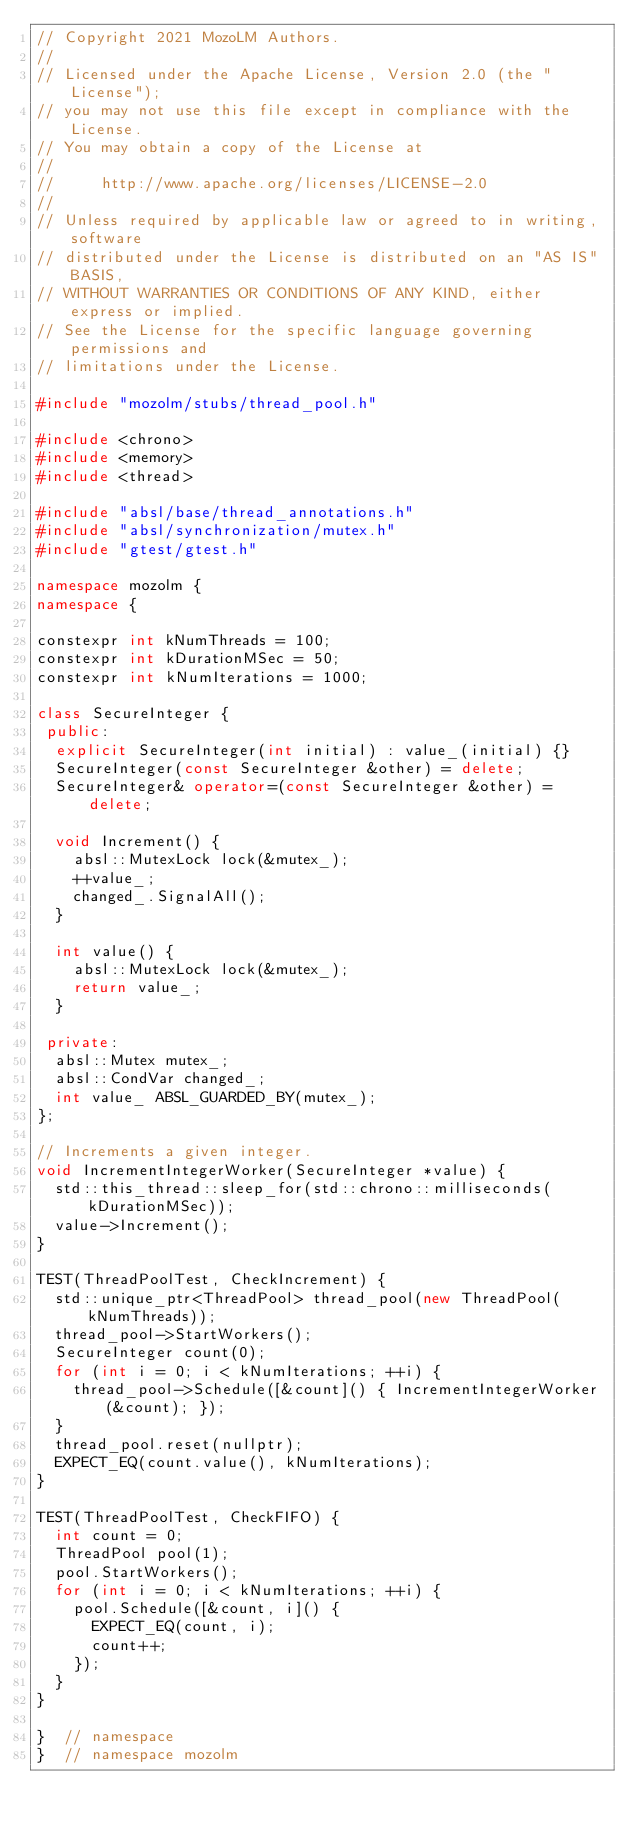<code> <loc_0><loc_0><loc_500><loc_500><_C++_>// Copyright 2021 MozoLM Authors.
//
// Licensed under the Apache License, Version 2.0 (the "License");
// you may not use this file except in compliance with the License.
// You may obtain a copy of the License at
//
//     http://www.apache.org/licenses/LICENSE-2.0
//
// Unless required by applicable law or agreed to in writing, software
// distributed under the License is distributed on an "AS IS" BASIS,
// WITHOUT WARRANTIES OR CONDITIONS OF ANY KIND, either express or implied.
// See the License for the specific language governing permissions and
// limitations under the License.

#include "mozolm/stubs/thread_pool.h"

#include <chrono>
#include <memory>
#include <thread>

#include "absl/base/thread_annotations.h"
#include "absl/synchronization/mutex.h"
#include "gtest/gtest.h"

namespace mozolm {
namespace {

constexpr int kNumThreads = 100;
constexpr int kDurationMSec = 50;
constexpr int kNumIterations = 1000;

class SecureInteger {
 public:
  explicit SecureInteger(int initial) : value_(initial) {}
  SecureInteger(const SecureInteger &other) = delete;
  SecureInteger& operator=(const SecureInteger &other) = delete;

  void Increment() {
    absl::MutexLock lock(&mutex_);
    ++value_;
    changed_.SignalAll();
  }

  int value() {
    absl::MutexLock lock(&mutex_);
    return value_;
  }

 private:
  absl::Mutex mutex_;
  absl::CondVar changed_;
  int value_ ABSL_GUARDED_BY(mutex_);
};

// Increments a given integer.
void IncrementIntegerWorker(SecureInteger *value) {
  std::this_thread::sleep_for(std::chrono::milliseconds(kDurationMSec));
  value->Increment();
}

TEST(ThreadPoolTest, CheckIncrement) {
  std::unique_ptr<ThreadPool> thread_pool(new ThreadPool(kNumThreads));
  thread_pool->StartWorkers();
  SecureInteger count(0);
  for (int i = 0; i < kNumIterations; ++i) {
    thread_pool->Schedule([&count]() { IncrementIntegerWorker(&count); });
  }
  thread_pool.reset(nullptr);
  EXPECT_EQ(count.value(), kNumIterations);
}

TEST(ThreadPoolTest, CheckFIFO) {
  int count = 0;
  ThreadPool pool(1);
  pool.StartWorkers();
  for (int i = 0; i < kNumIterations; ++i) {
    pool.Schedule([&count, i]() {
      EXPECT_EQ(count, i);
      count++;
    });
  }
}

}  // namespace
}  // namespace mozolm
</code> 